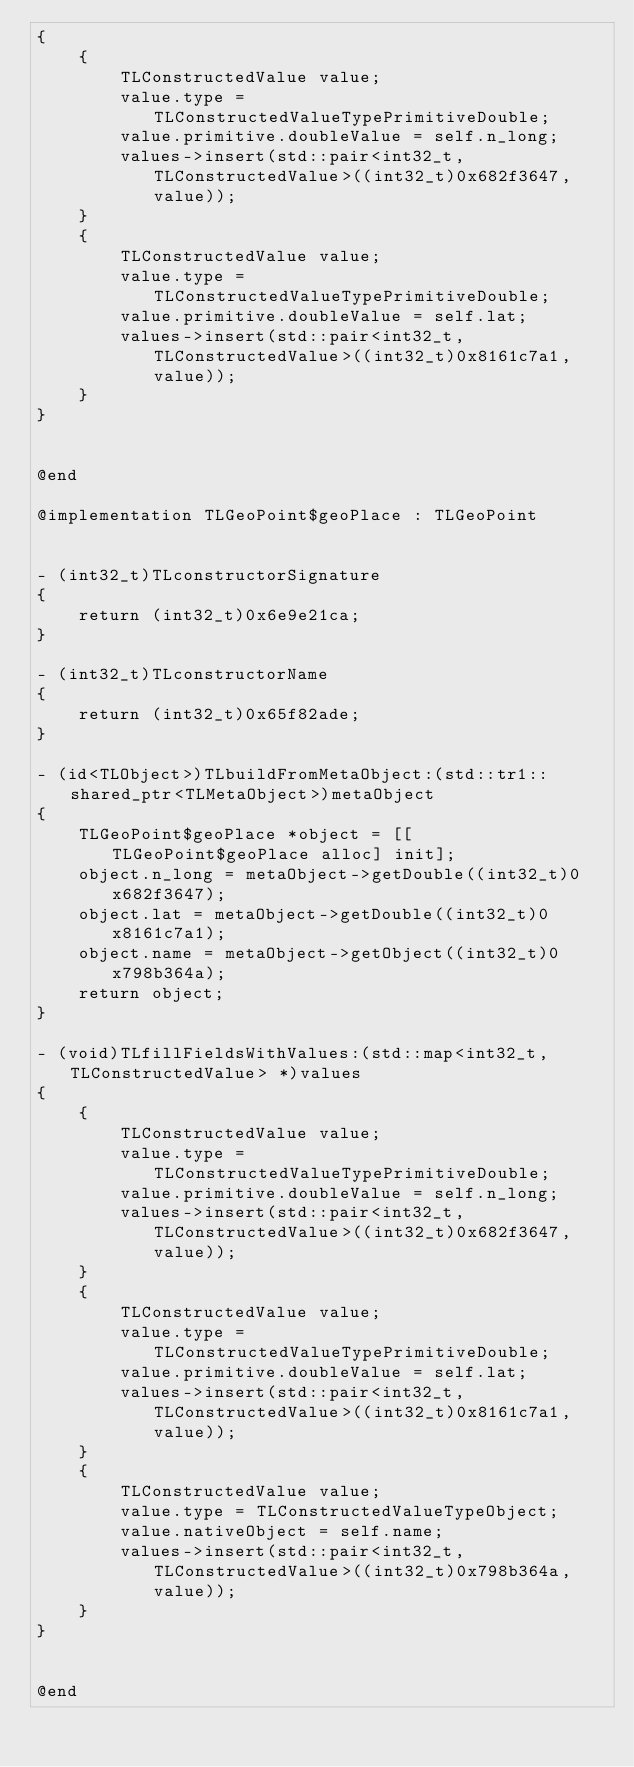<code> <loc_0><loc_0><loc_500><loc_500><_ObjectiveC_>{
    {
        TLConstructedValue value;
        value.type = TLConstructedValueTypePrimitiveDouble;
        value.primitive.doubleValue = self.n_long;
        values->insert(std::pair<int32_t, TLConstructedValue>((int32_t)0x682f3647, value));
    }
    {
        TLConstructedValue value;
        value.type = TLConstructedValueTypePrimitiveDouble;
        value.primitive.doubleValue = self.lat;
        values->insert(std::pair<int32_t, TLConstructedValue>((int32_t)0x8161c7a1, value));
    }
}


@end

@implementation TLGeoPoint$geoPlace : TLGeoPoint


- (int32_t)TLconstructorSignature
{
    return (int32_t)0x6e9e21ca;
}

- (int32_t)TLconstructorName
{
    return (int32_t)0x65f82ade;
}

- (id<TLObject>)TLbuildFromMetaObject:(std::tr1::shared_ptr<TLMetaObject>)metaObject
{
    TLGeoPoint$geoPlace *object = [[TLGeoPoint$geoPlace alloc] init];
    object.n_long = metaObject->getDouble((int32_t)0x682f3647);
    object.lat = metaObject->getDouble((int32_t)0x8161c7a1);
    object.name = metaObject->getObject((int32_t)0x798b364a);
    return object;
}

- (void)TLfillFieldsWithValues:(std::map<int32_t, TLConstructedValue> *)values
{
    {
        TLConstructedValue value;
        value.type = TLConstructedValueTypePrimitiveDouble;
        value.primitive.doubleValue = self.n_long;
        values->insert(std::pair<int32_t, TLConstructedValue>((int32_t)0x682f3647, value));
    }
    {
        TLConstructedValue value;
        value.type = TLConstructedValueTypePrimitiveDouble;
        value.primitive.doubleValue = self.lat;
        values->insert(std::pair<int32_t, TLConstructedValue>((int32_t)0x8161c7a1, value));
    }
    {
        TLConstructedValue value;
        value.type = TLConstructedValueTypeObject;
        value.nativeObject = self.name;
        values->insert(std::pair<int32_t, TLConstructedValue>((int32_t)0x798b364a, value));
    }
}


@end

</code> 